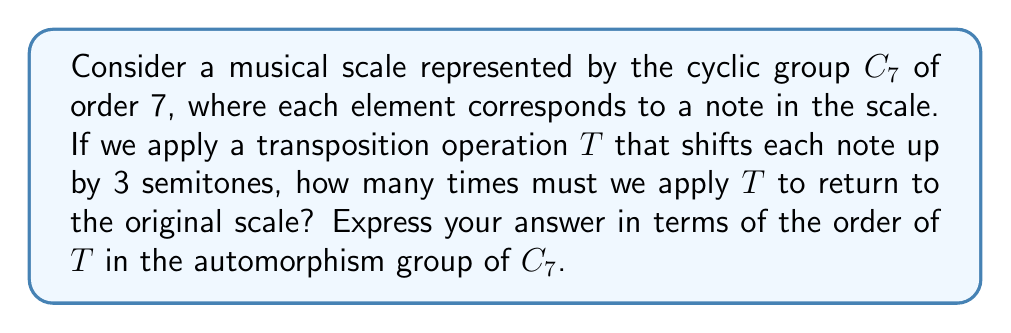Solve this math problem. Let's approach this step-by-step:

1) The cyclic group $C_7$ represents a 7-note scale, where each element can be thought of as a note in the scale.

2) The transposition operation $T$ that shifts each note up by 3 semitones can be represented as the automorphism $T: x \mapsto x + 3 \pmod{7}$ in $C_7$.

3) To find how many times we need to apply $T$ to return to the original scale, we need to find the order of $T$ in the automorphism group of $C_7$.

4) The order of $T$ is the smallest positive integer $n$ such that $T^n$ is the identity automorphism.

5) Let's apply $T$ repeatedly:
   $T(x) = x + 3 \pmod{7}$
   $T^2(x) = (x + 3) + 3 = x + 6 \pmod{7}$
   $T^3(x) = x + 9 = x + 2 \pmod{7}$
   $T^4(x) = x + 5 \pmod{7}$
   $T^5(x) = x + 1 \pmod{7}$
   $T^6(x) = x + 4 \pmod{7}$
   $T^7(x) = x \pmod{7}$

6) We see that $T^7$ is the identity automorphism, so the order of $T$ is 7.

7) This result is not coincidental. In fact, for any transposition in $C_7$ that doesn't map to the identity, the order will always be 7. This is because 7 is prime, making $C_7$ a simple group where any non-trivial automorphism generates the entire automorphism group.

8) Musically, this means that after transposing the scale 7 times by 3 semitones each time, we return to the original scale, having cycled through all possible transpositions.
Answer: 7 